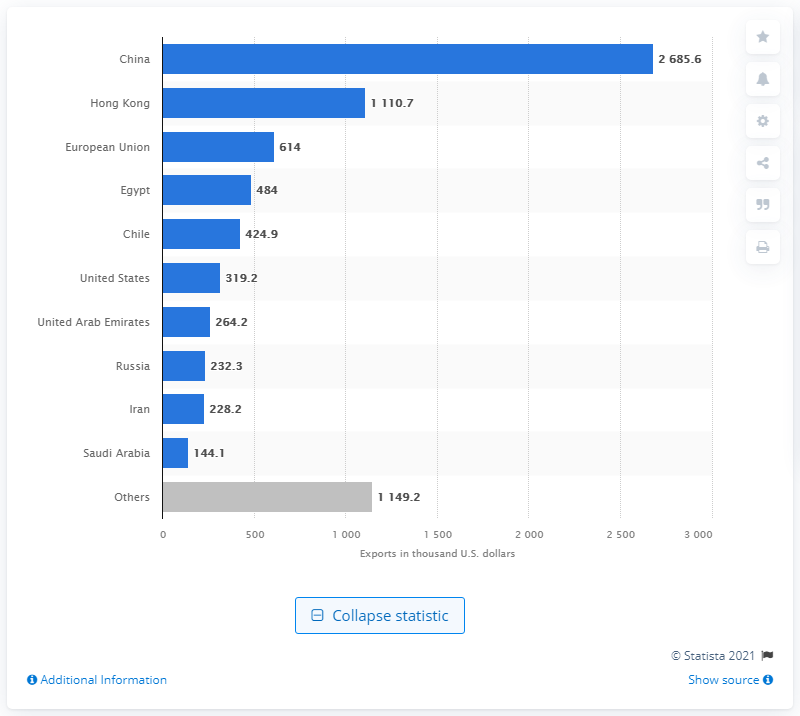Point out several critical features in this image. In 2019, China exported 26,856 metric tons of beef to the United States. In 2019, the value of beef and veal exported to the European Union was 614 million US dollars. In 2019, China was Brazil's primary export partner for beef and veal. 